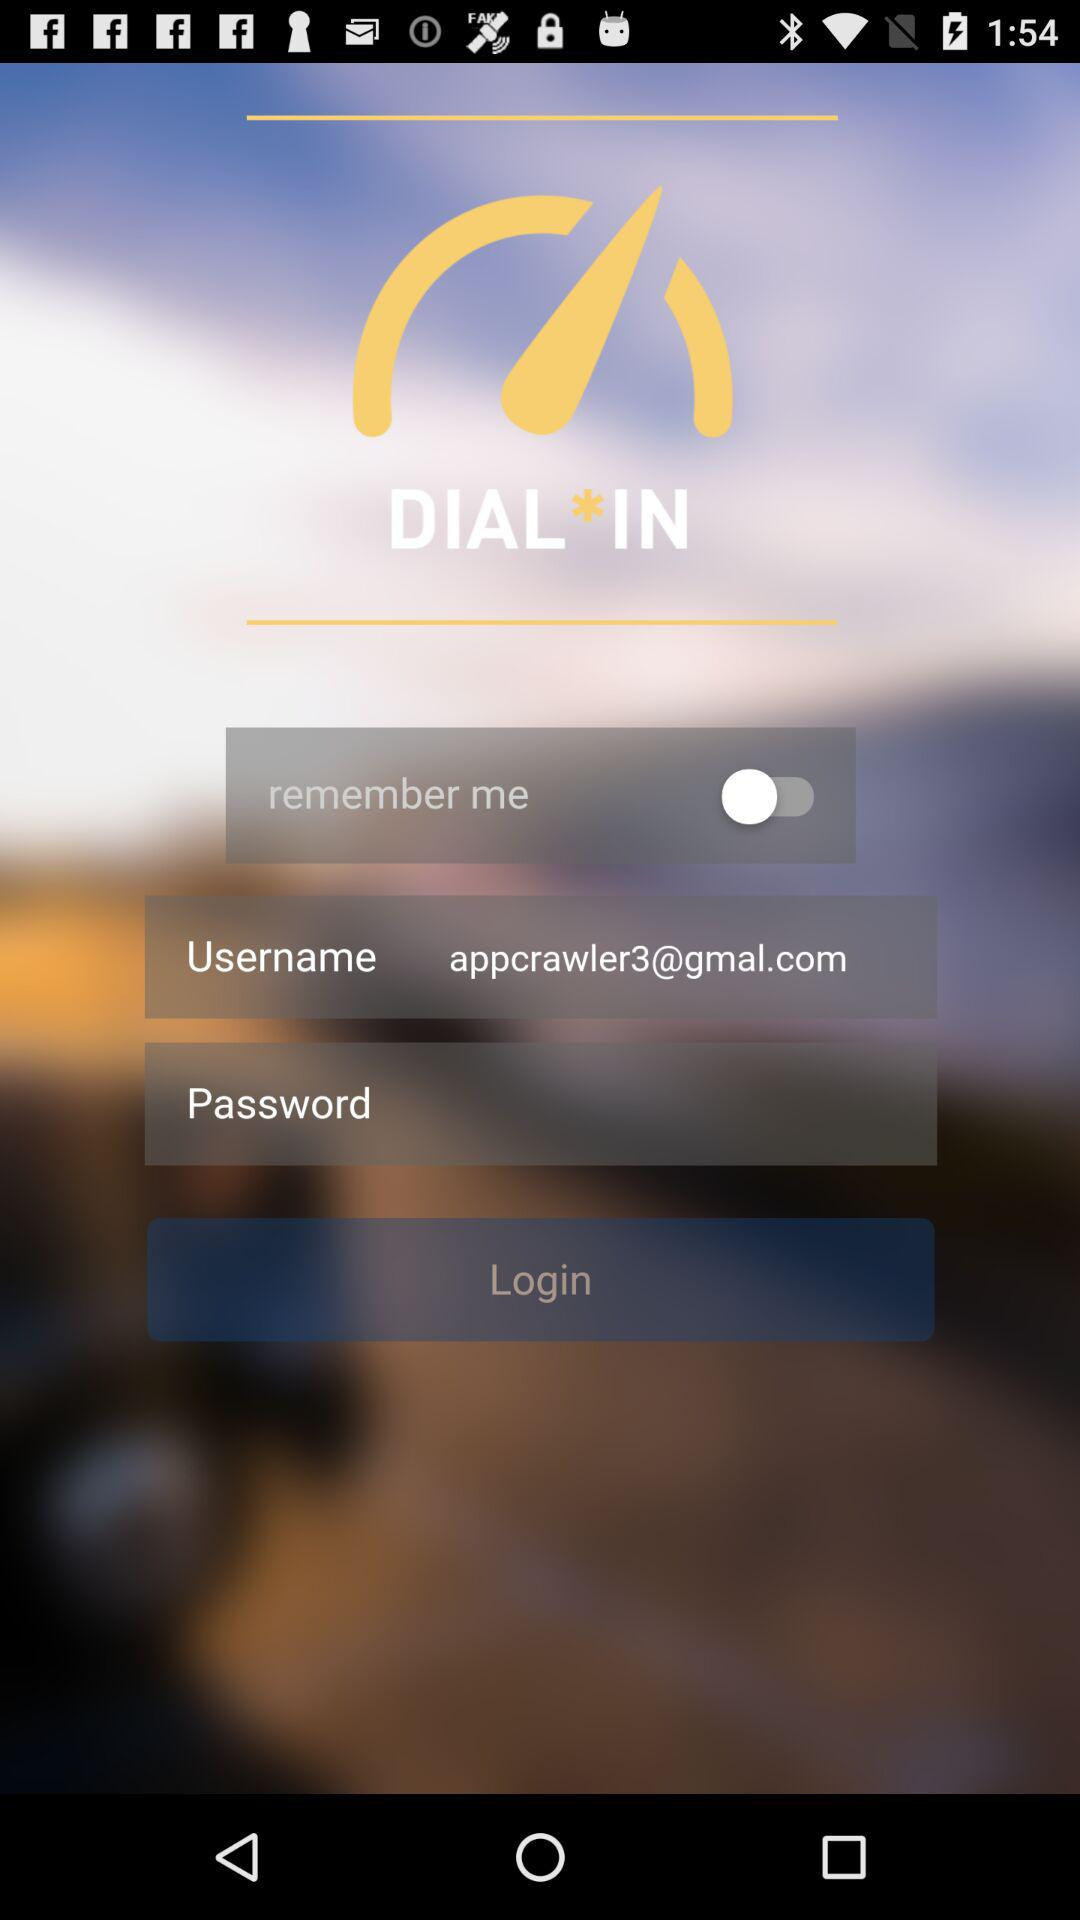How many characters are required to create a password?
When the provided information is insufficient, respond with <no answer>. <no answer> 